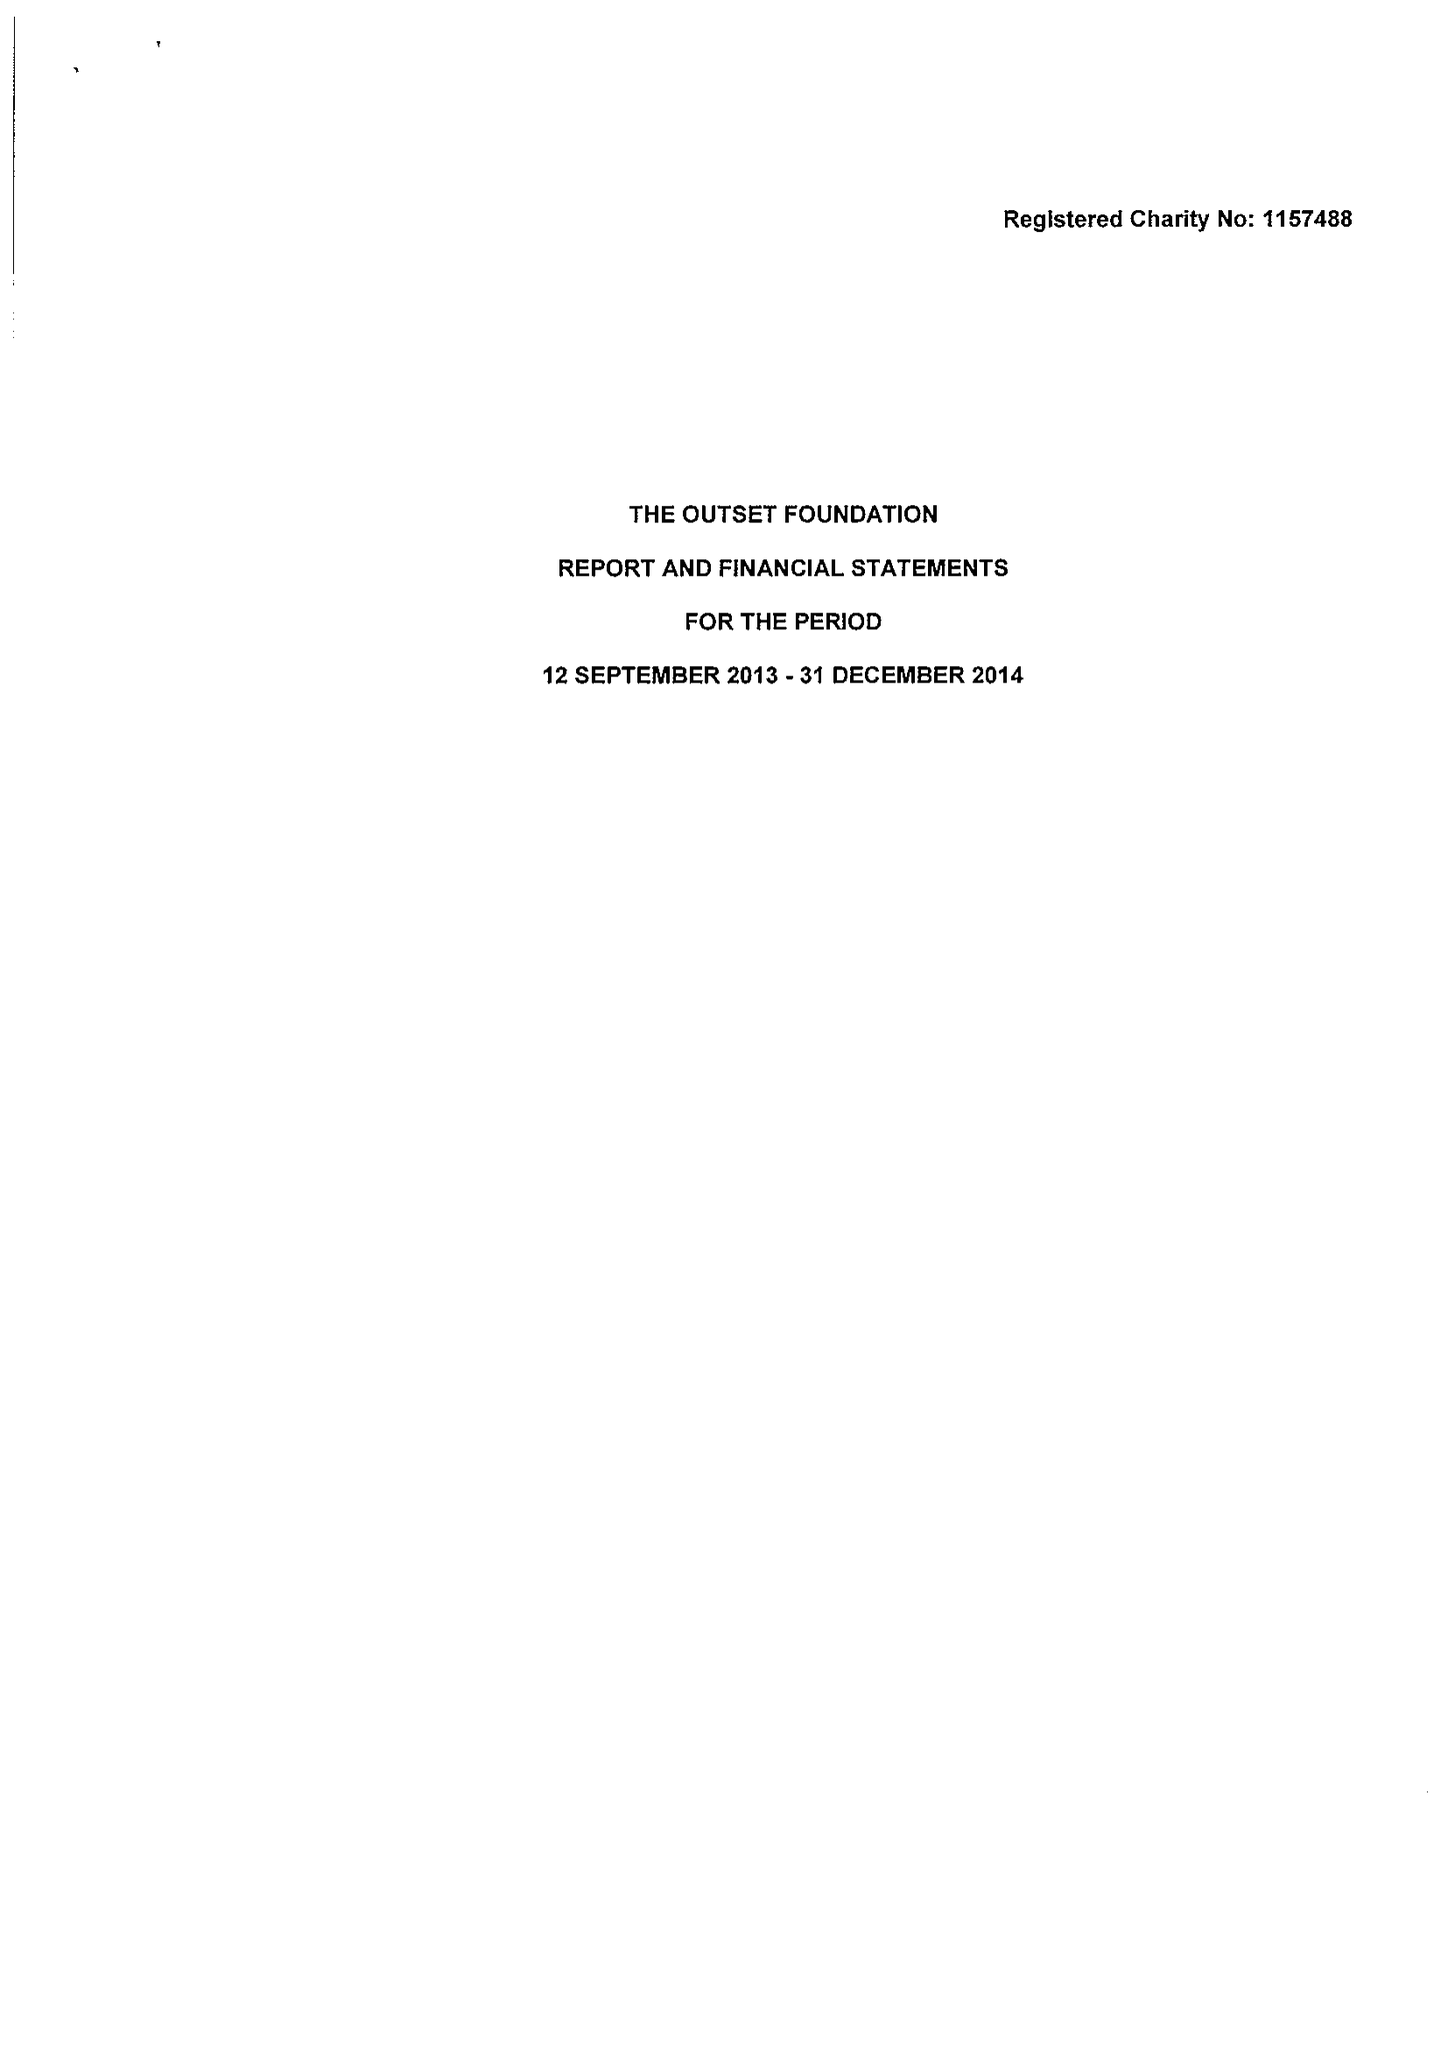What is the value for the charity_name?
Answer the question using a single word or phrase. The Outset Foundation 